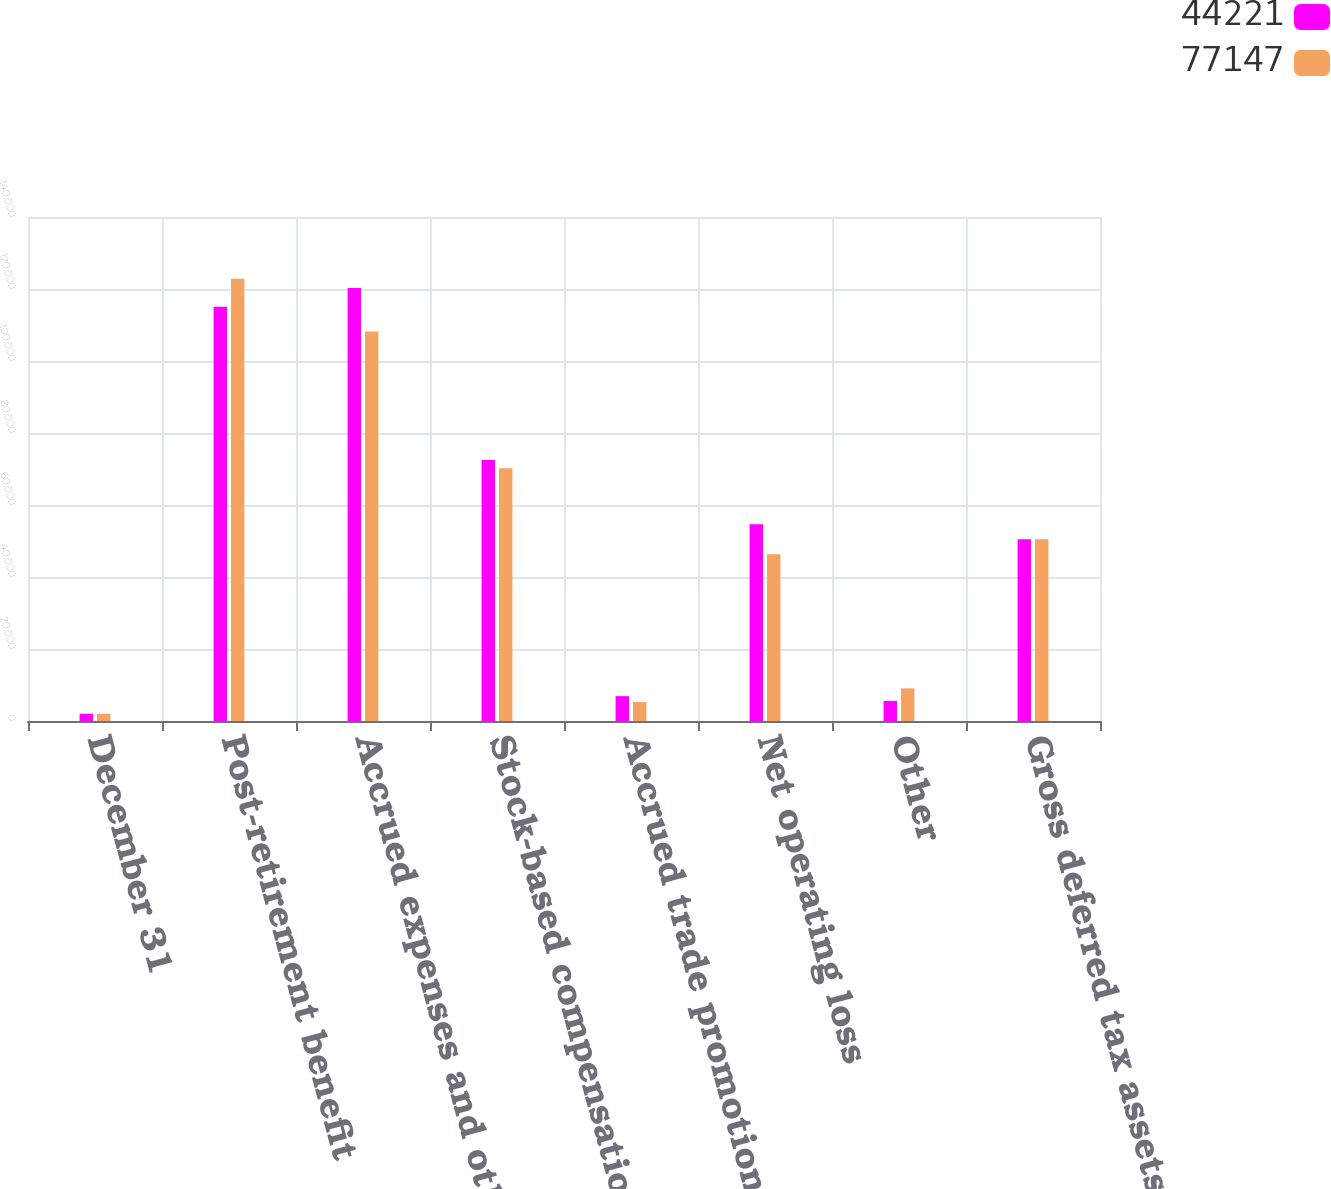Convert chart. <chart><loc_0><loc_0><loc_500><loc_500><stacked_bar_chart><ecel><fcel>December 31<fcel>Post-retirement benefit<fcel>Accrued expenses and other<fcel>Stock-based compensation<fcel>Accrued trade promotion<fcel>Net operating loss<fcel>Other<fcel>Gross deferred tax assets<nl><fcel>44221<fcel>2010<fcel>115068<fcel>120258<fcel>72498<fcel>6902<fcel>54649<fcel>5598<fcel>50472.5<nl><fcel>77147<fcel>2009<fcel>122815<fcel>108181<fcel>70224<fcel>5282<fcel>46296<fcel>9075<fcel>50472.5<nl></chart> 